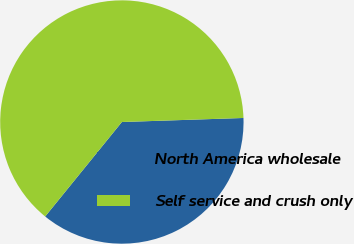Convert chart. <chart><loc_0><loc_0><loc_500><loc_500><pie_chart><fcel>North America wholesale<fcel>Self service and crush only<nl><fcel>36.38%<fcel>63.62%<nl></chart> 